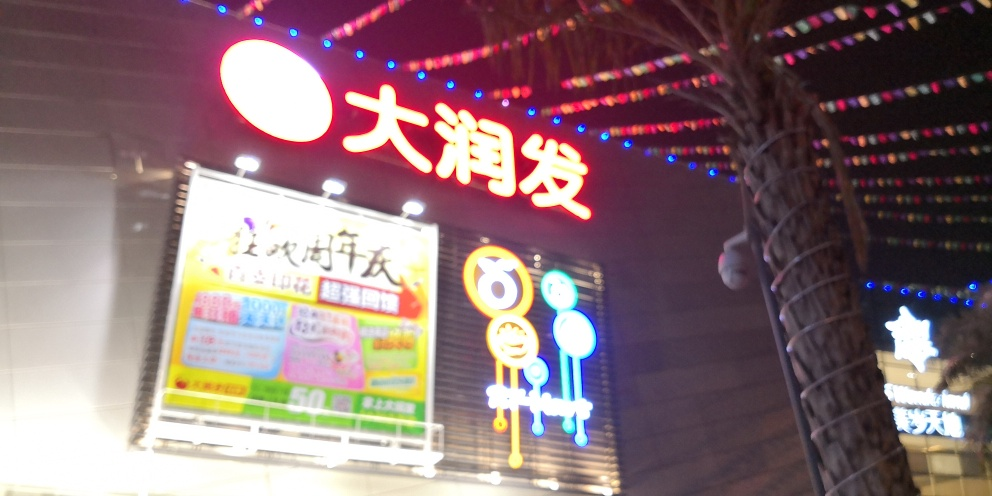What is the overall sharpness of the image? The sharpness of the image is quite low, which is evident from the visible blur and lack of clear details. This could be due to motion, incorrect focus, or a low-quality camera sensor. 